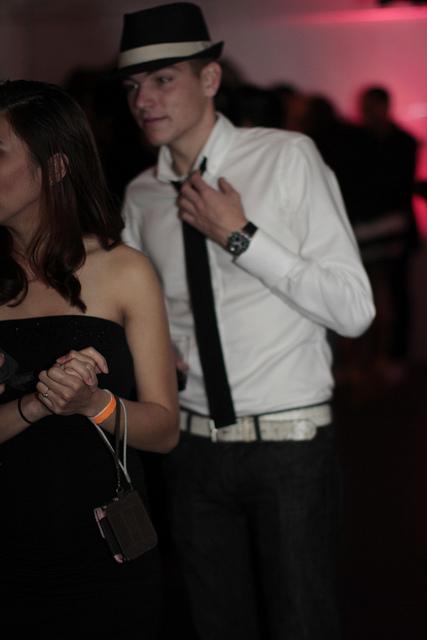Who is wearing the tie?
Be succinct. Man. Are these people wearing jackets?
Be succinct. No. What color is the tie on the right?
Answer briefly. Black. What is the occasion?
Concise answer only. Prom. What color is the man's belt?
Write a very short answer. White. What kind of hat is he wearing?
Write a very short answer. Fedora. 